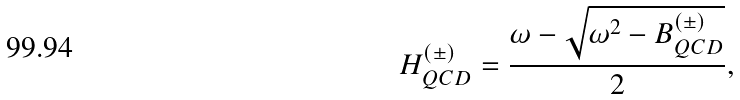<formula> <loc_0><loc_0><loc_500><loc_500>H ^ { ( \pm ) } _ { Q C D } = \frac { \omega - \sqrt { \omega ^ { 2 } - B ^ { ( \pm ) } _ { Q C D } } } { 2 } ,</formula> 